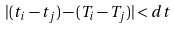<formula> <loc_0><loc_0><loc_500><loc_500>| ( t _ { i } - t _ { j } ) - ( T _ { i } - T _ { j } ) | < d t</formula> 